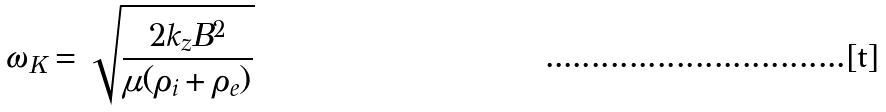Convert formula to latex. <formula><loc_0><loc_0><loc_500><loc_500>\omega _ { K } = \sqrt { \frac { 2 k _ { z } B ^ { 2 } } { \mu ( \rho _ { i } + \rho _ { e } ) } }</formula> 